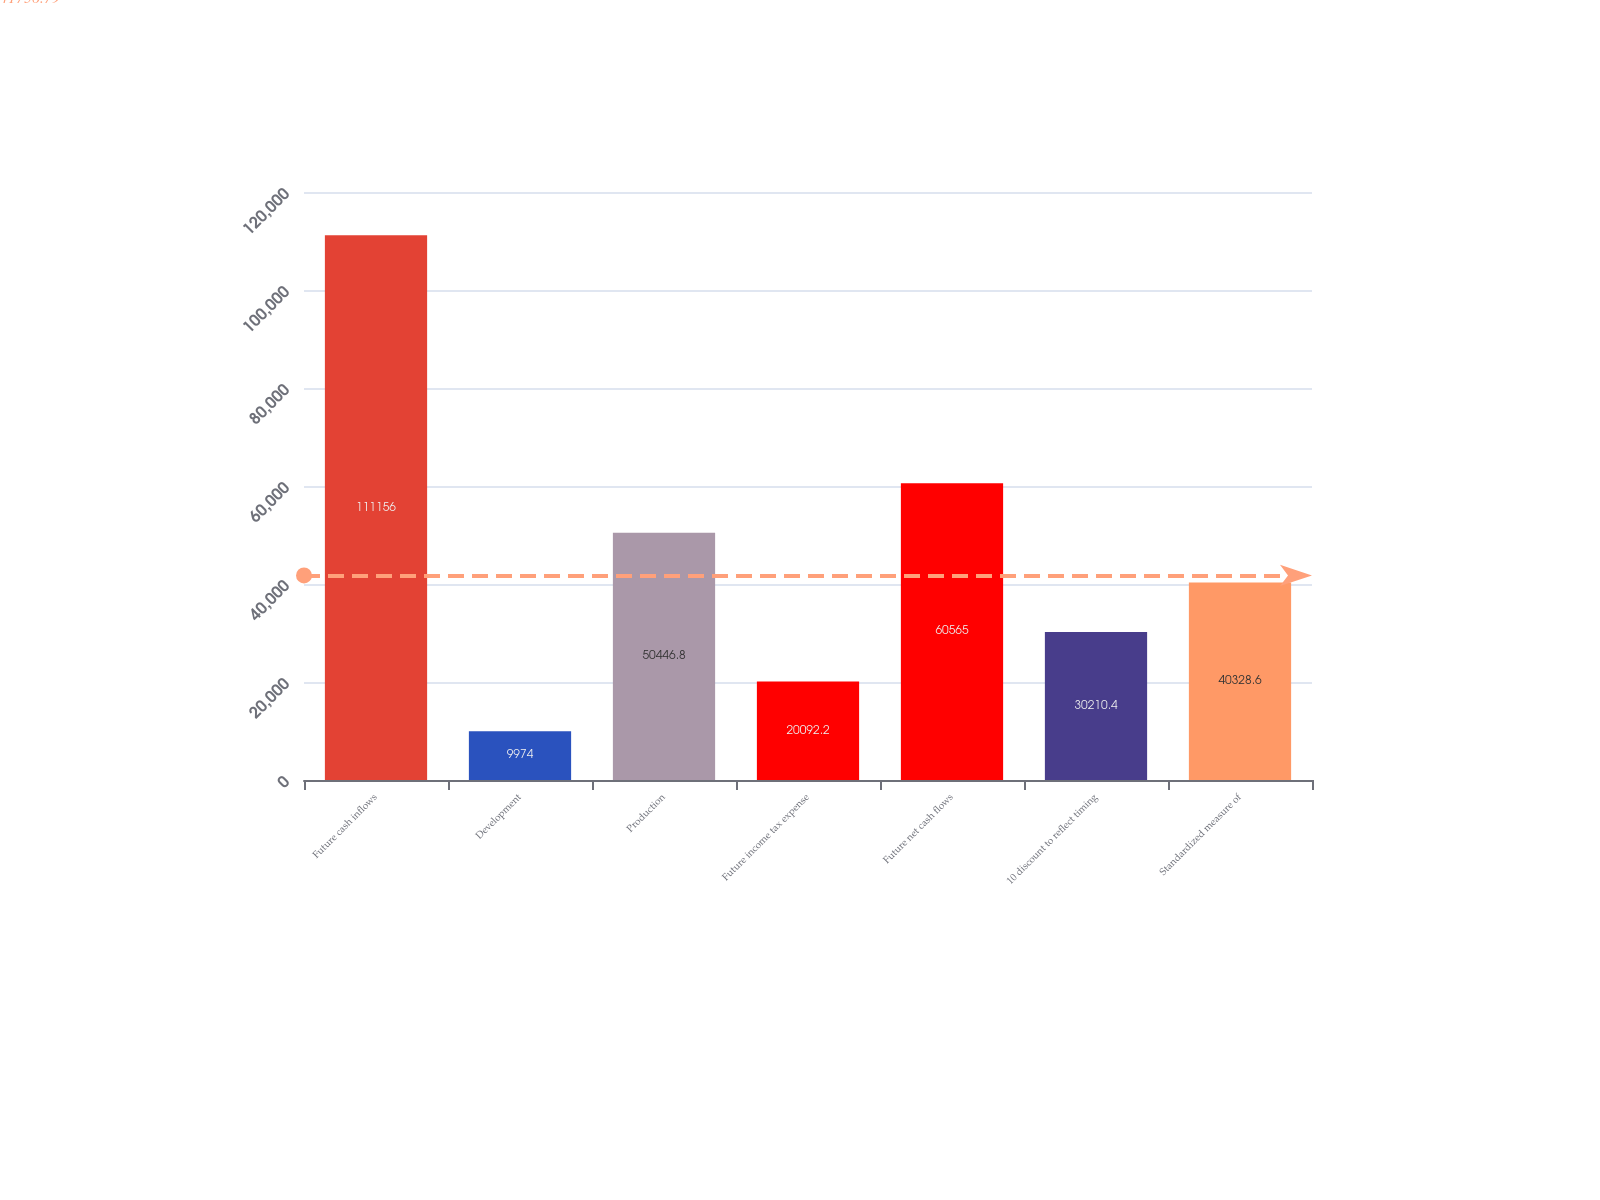Convert chart to OTSL. <chart><loc_0><loc_0><loc_500><loc_500><bar_chart><fcel>Future cash inflows<fcel>Development<fcel>Production<fcel>Future income tax expense<fcel>Future net cash flows<fcel>10 discount to reflect timing<fcel>Standardized measure of<nl><fcel>111156<fcel>9974<fcel>50446.8<fcel>20092.2<fcel>60565<fcel>30210.4<fcel>40328.6<nl></chart> 